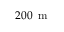Convert formula to latex. <formula><loc_0><loc_0><loc_500><loc_500>2 0 0 \, m</formula> 